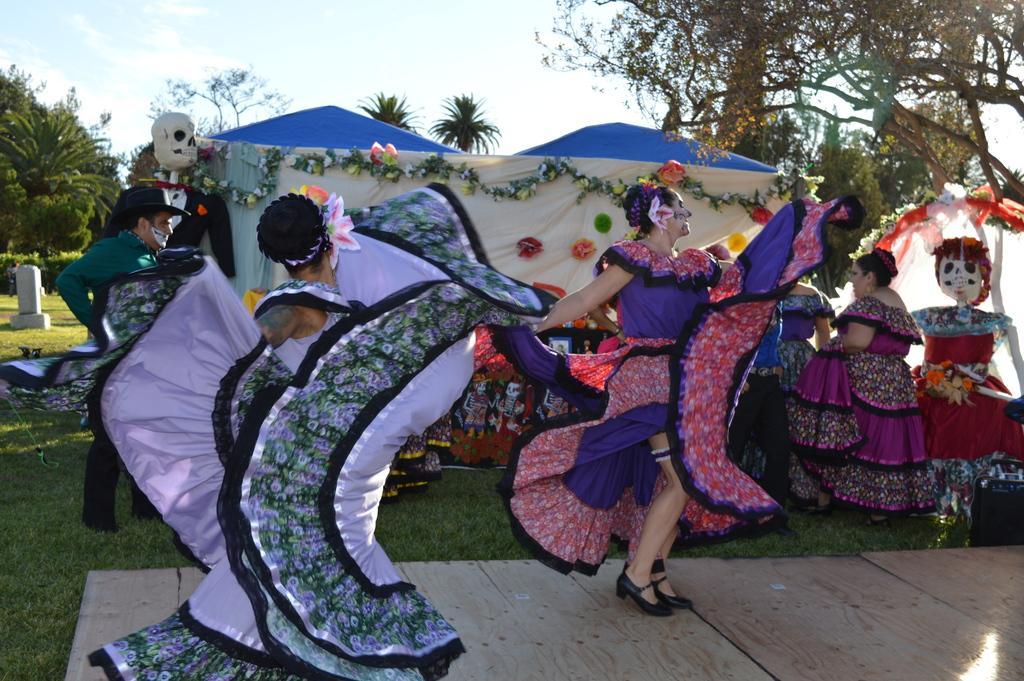Could you give a brief overview of what you see in this image? In this image we can see people wearing costumes. At the bottom of the image there is wooden floor, grass. In the background of the image there are trees and sky. 